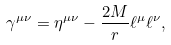Convert formula to latex. <formula><loc_0><loc_0><loc_500><loc_500>\gamma ^ { \mu \nu } = \eta ^ { \mu \nu } - \frac { 2 M } { r } \ell ^ { \mu } \ell ^ { \nu } ,</formula> 